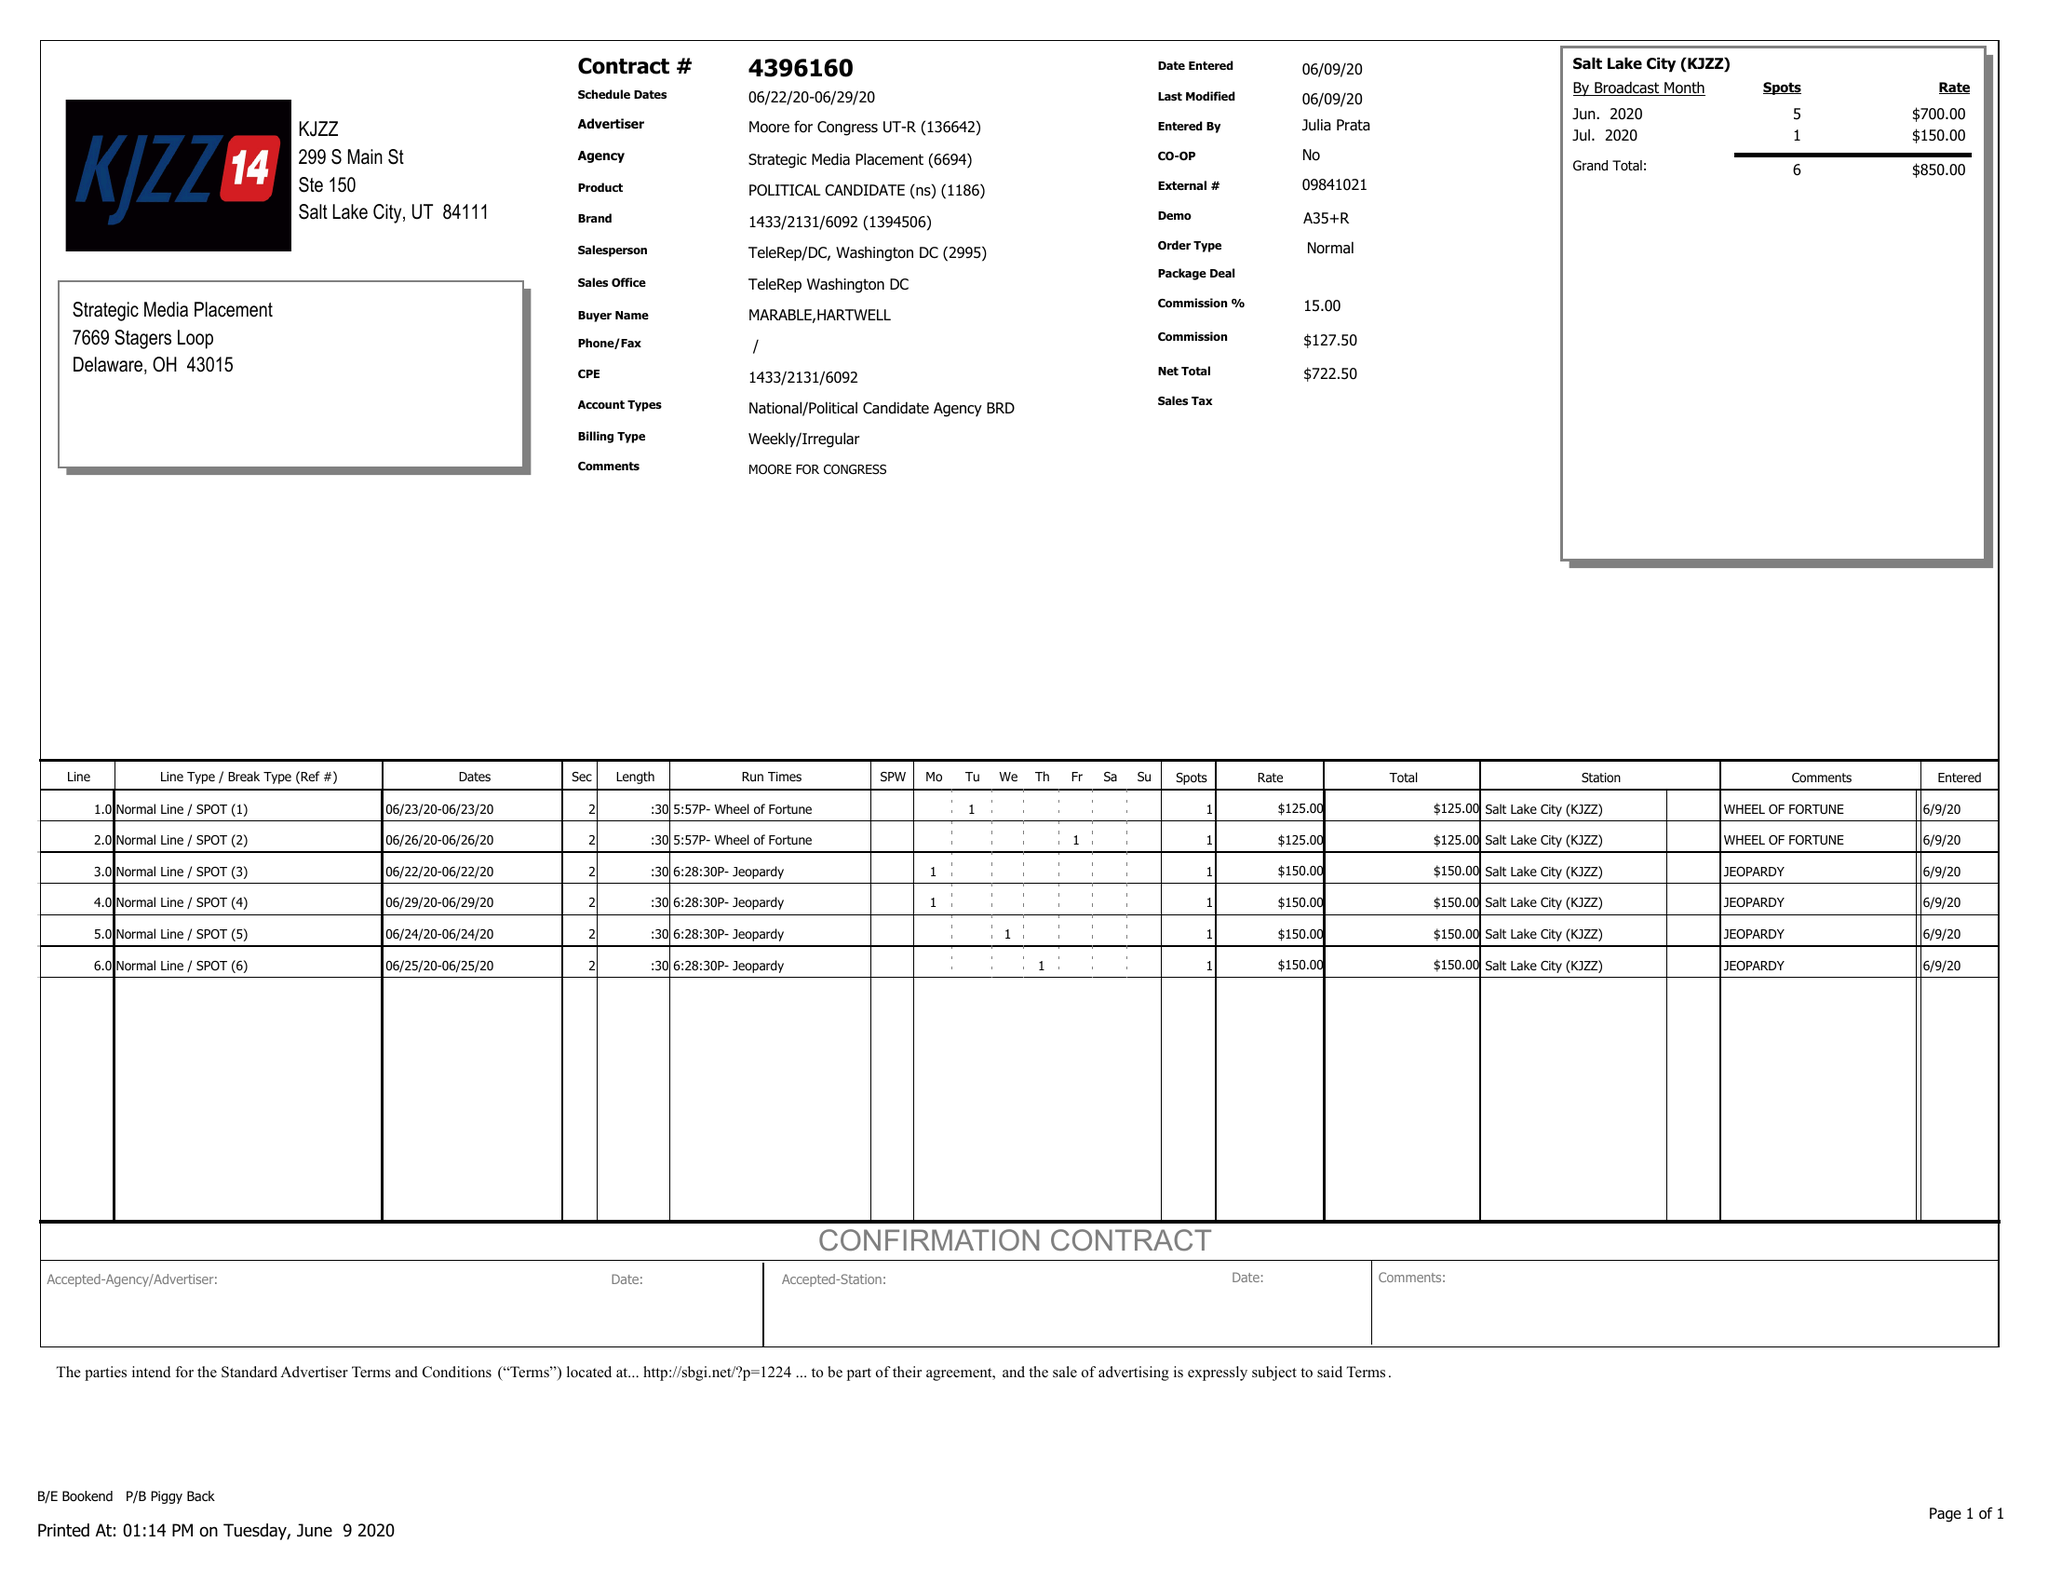What is the value for the flight_to?
Answer the question using a single word or phrase. 06/29/20 